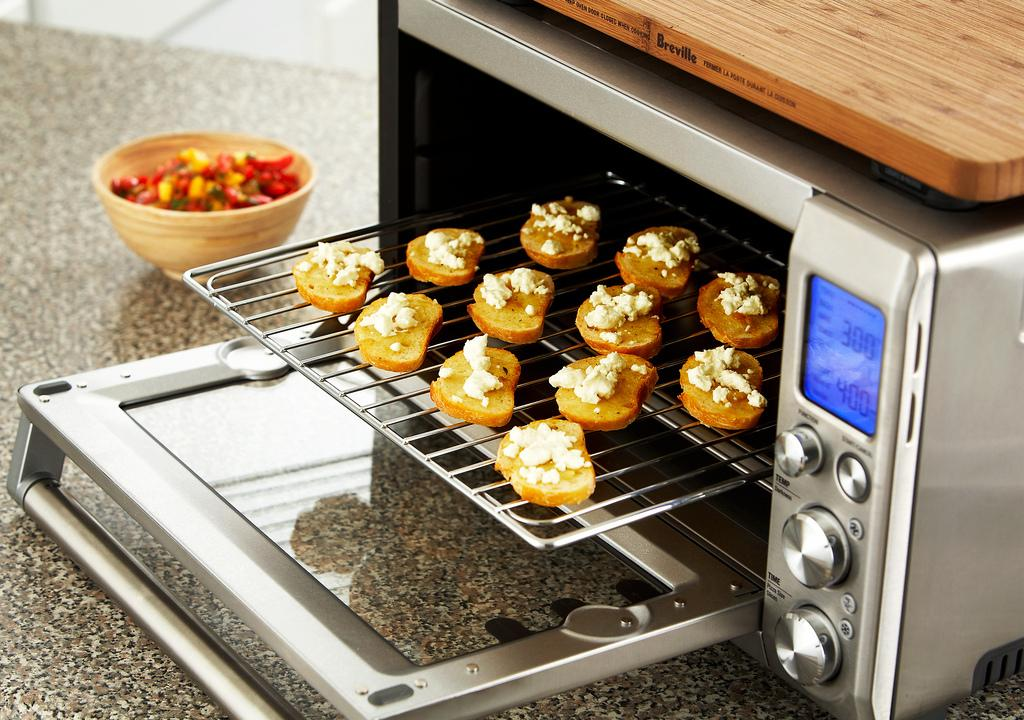Provide a one-sentence caption for the provided image. 300 to 400 degrees is what this mini oven is set at. 